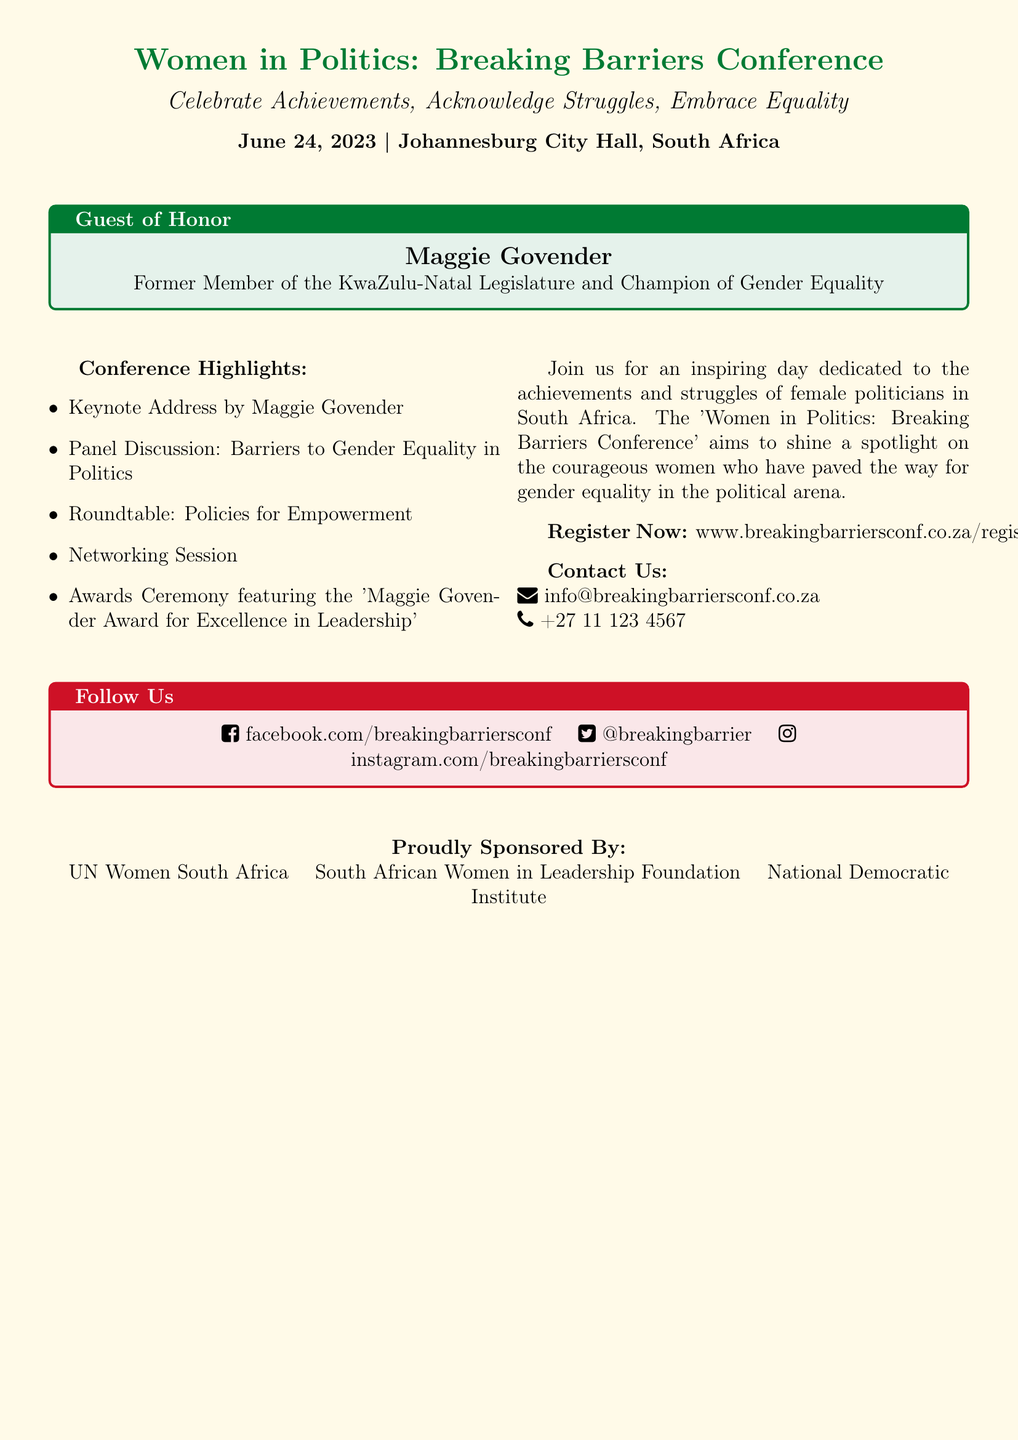What is the date of the conference? The date of the conference is explicitly mentioned in the document.
Answer: June 24, 2023 Who is the guest of honor? The document clearly states the guest of honor's name and title.
Answer: Maggie Govender What is the award being presented at the conference? The document mentions a specific award associated with the conference.
Answer: Maggie Govender Award for Excellence in Leadership What city is hosting the conference? The location of the conference is stated in the document.
Answer: Johannesburg What type of session is included in the conference highlights? The document lists various sessions, one of which is highlighted.
Answer: Networking Session Which organizations are sponsoring the event? The document names organizations that are sponsoring the event.
Answer: UN Women South Africa, South African Women in Leadership Foundation, National Democratic Institute What is the main theme of the conference? The document emphasizes the central idea or theme of the conference.
Answer: Gender equality in politics What is the purpose of the Women in Politics: Breaking Barriers Conference? The document describes the purpose and intent of the conference.
Answer: Shine a spotlight on the courageous women who have paved the way for gender equality in the political arena 